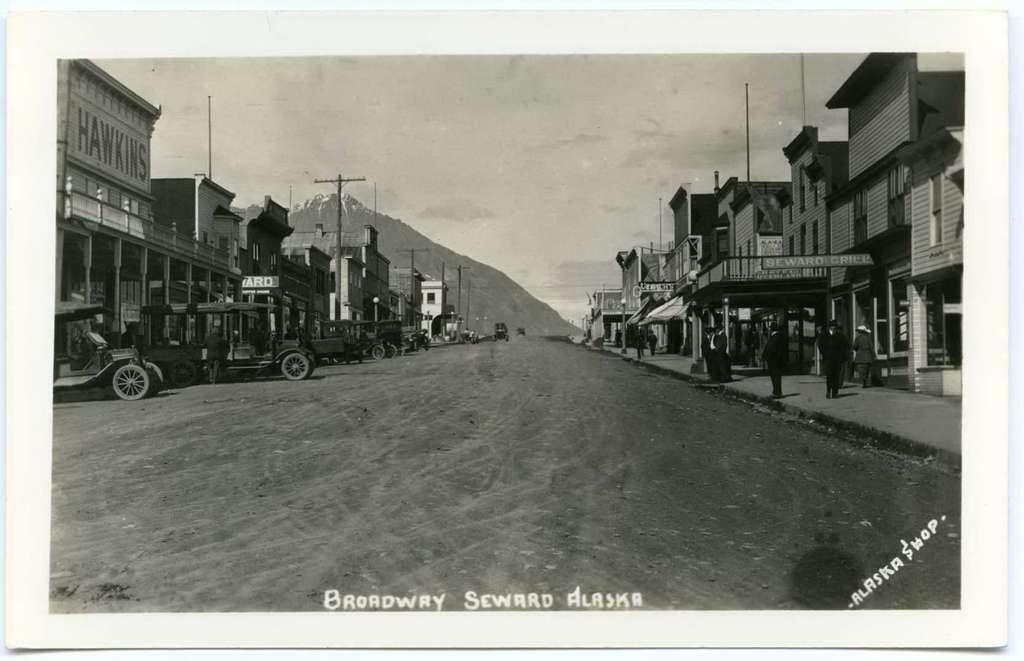Please provide a concise description of this image. This picture few buildings and we see few electrical poles and people standing on the sidewalk and couple of cars moving on the road and the few cars parked on the side and we see a cloudy sky and we see text on the bottom and right bottom of the picture. 